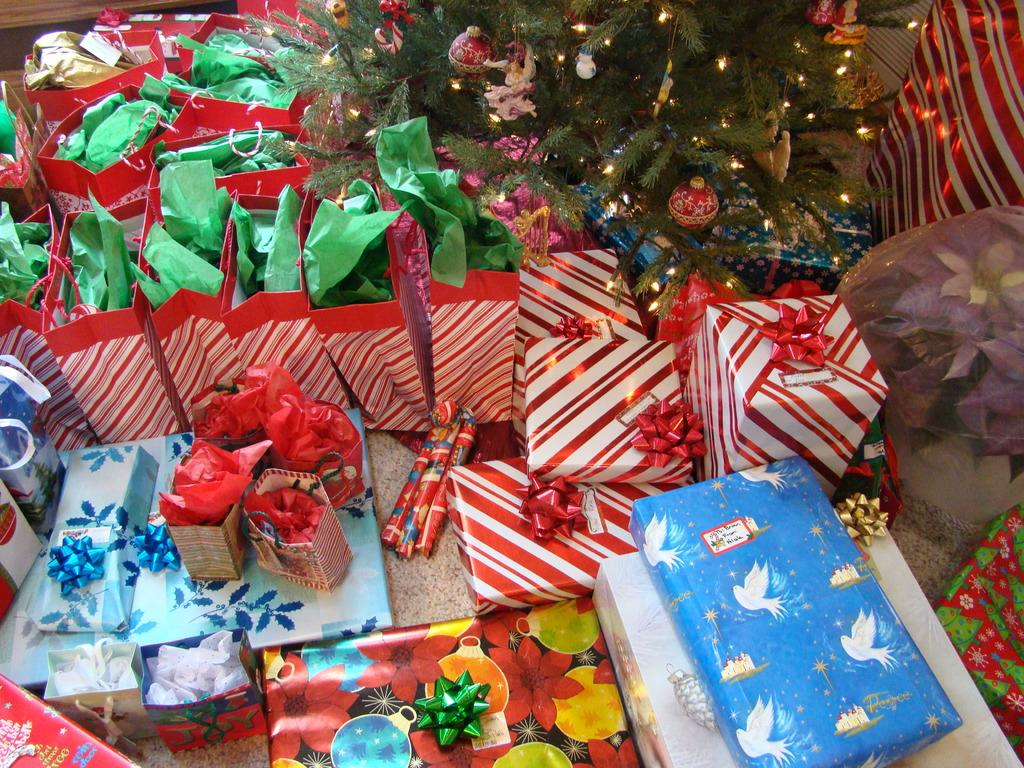What objects are present in the image that are related to gift-giving? There are gift packs in the image. What holiday-related object can be seen in the image? There is a Christmas tree in the image. What decorative feature is present on the Christmas tree? The Christmas tree has lights on it. What thrill can be experienced by the owner of the gift packs in the image? There is no indication in the image of the owner's experience or emotions, nor is there any mention of a thrill. --- Facts: 1. There is a person holding a book in the image. 2. The book has a blue cover. 3. The person is sitting on a chair. 4. There is a table next to the chair. Absurd Topics: dance, ocean, instrument Conversation: What is the person in the image holding? The person is holding a book in the image. What color is the book's cover? The book has a blue cover. What type of furniture is the person sitting on? The person is sitting on a chair. What is located next to the chair? There is a table next to the chair. Reasoning: Let's think step by step in order to produce the conversation. We start by identifying the main subject in the image, which is the person holding a book. Then, we expand the conversation to include details about the book, such as its color. Next, we describe the person's position and the furniture they are using, which is a chair. Finally, we mention the presence of a table next to the chair. Each question is designed to elicit a specific detail about the image that is known from the provided facts. Absurd Question/Answer: What type of dance is the person performing in the image? There is no indication in the image that the person is dancing or performing any type of dance. 